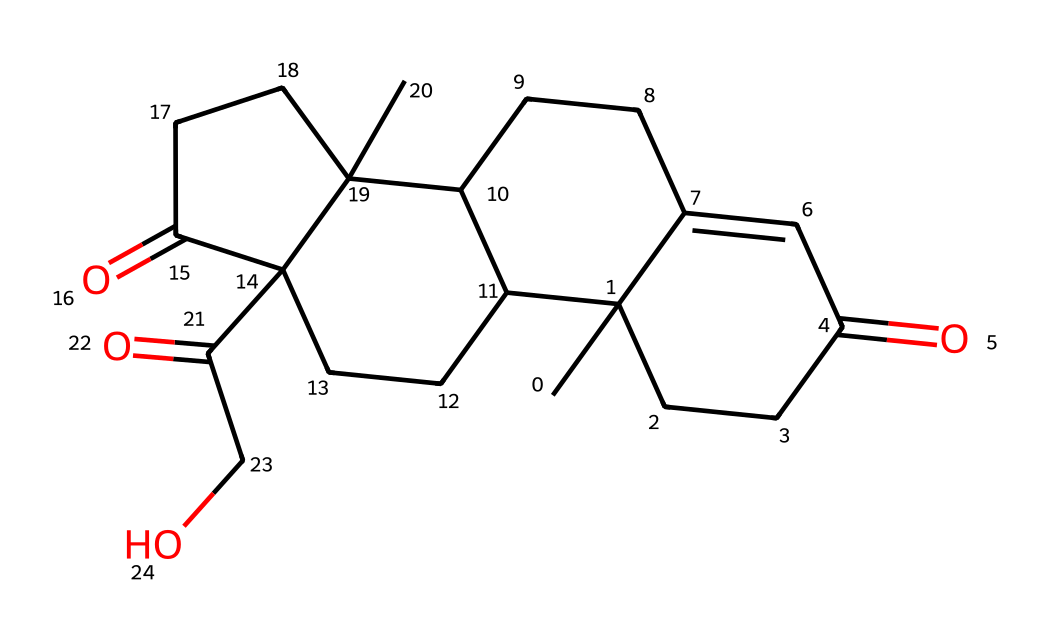What is the molecular formula of cortisol? The SMILES representation can be analyzed to determine the number of carbon, hydrogen, and oxygen atoms present. By counting from the structure, cortisol has 21 carbon atoms, 30 hydrogen atoms, and 5 oxygen atoms. This gives the molecular formula C21H30O5.
Answer: C21H30O5 How many rings are present in the cortisol structure? A visual inspection of the structure reveals multiple cyclic components. Counting these cycles in the drawn structure shows that there are four rings present in cortisol.
Answer: 4 What functional groups are represented in cortisol? Analyzing the structure of cortisol reveals the presence of ketone groups (C=O) and a hydroxyl group (–OH). These functional groups are vital for the chemical's biological activity.
Answer: ketone, hydroxyl What is the role of cortisol in the human body? Cortisol is known for its role in the stress response and regulation of metabolism. It interacts with various tissues, helping manage blood sugar levels and metabolism.
Answer: stress response, metabolism What is the ideal pH range for cortisol solubility? The solubility of cortisol can be influenced by its functional groups and molecular structure, typically showing higher solubility in slightly acidic to neutral pH, typically around 6 to 7.
Answer: 6-7 Is cortisol a steroid hormone? Cortisol is derived from cholesterol and fits within the class of steroid hormones due to its structure and function in the body, influencing metabolism, immune response, and stress.
Answer: yes What might happen if there's an imbalance in cortisol levels? An imbalance in cortisol can lead to conditions such as Cushing's syndrome or Addison's disease, affecting metabolism, stress response, and overall health negatively.
Answer: health issues 